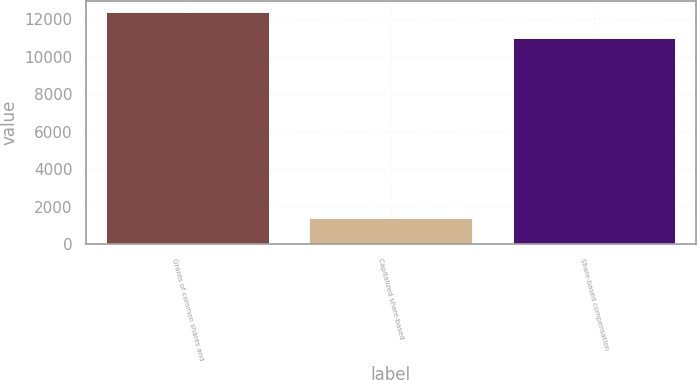Convert chart to OTSL. <chart><loc_0><loc_0><loc_500><loc_500><bar_chart><fcel>Grants of common shares and<fcel>Capitalized share-based<fcel>Share-based compensation<nl><fcel>12371<fcel>1385<fcel>10986<nl></chart> 